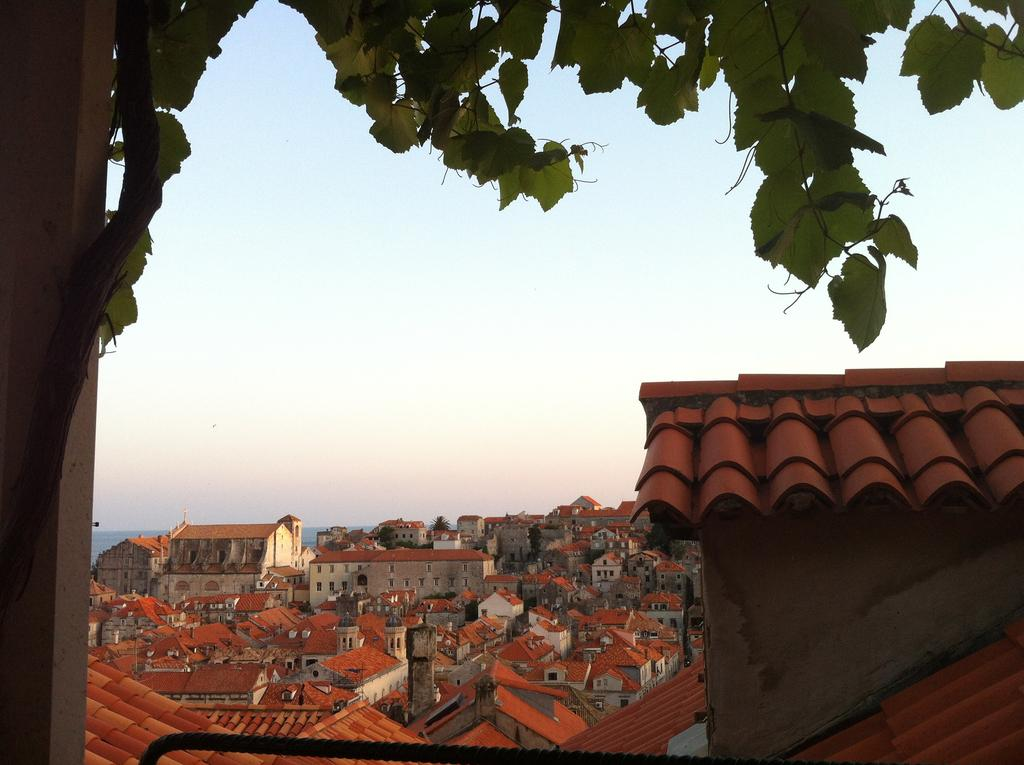What type of structures can be seen in the image? There are many buildings in the image. What part of the buildings is visible? The windows of the buildings are visible. What type of vegetation is present in the image? There is a tree in the image. What architectural feature can be seen in the image? There is a pillar in the image. What natural element is visible in the image? There is water visible in the image. What part of the environment is visible in the image? The sky is visible in the image. How many needles are sticking out of the tree in the image? There are no needles present in the image; it features a tree with leaves or branches. What is the amount of roof visible in the image? There is no roof visible in the image, as it focuses on buildings and their windows. 